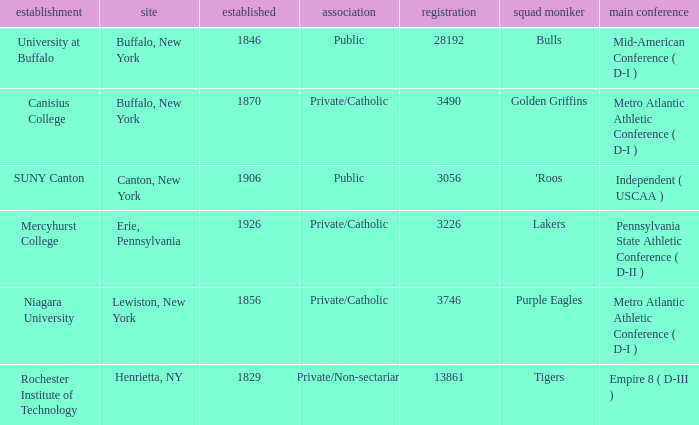What kind of school is Canton, New York? Public. 